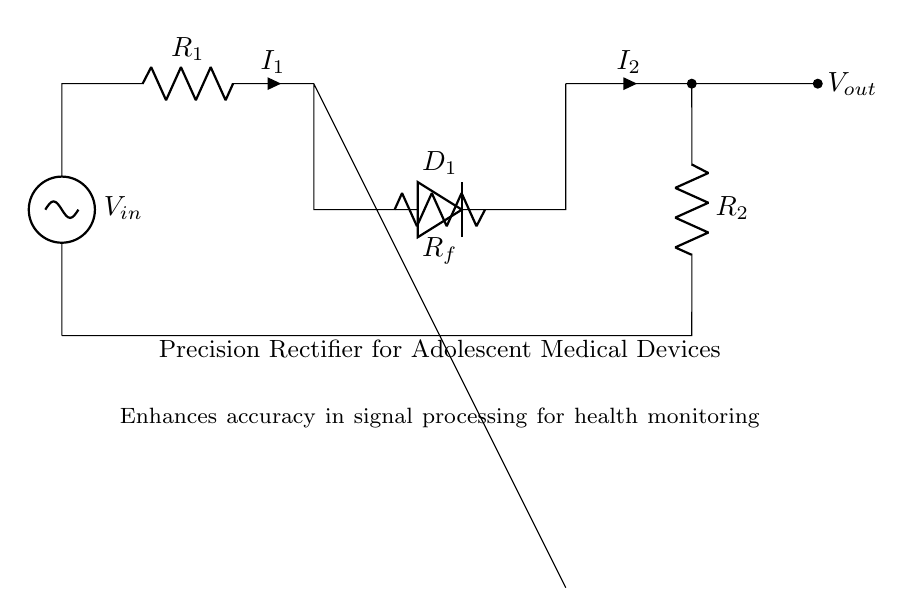What type of circuit is represented here? This circuit diagram represents a precision rectifier, which is designed to rectify small input signals accurately without the typical voltage drop found in standard diodes.
Answer: precision rectifier What are the main components in this circuit? The main components include two resistors (R1 and R2), one op-amp, and one diode (D1). These are essential for the functioning of the precision rectifier.
Answer: resistors, op-amp, diode What is the role of the op-amp in this circuit? The op-amp amplifies the input signal and helps in achieving precision rectification by controlling the behavior of the diode during the rectification process.
Answer: amplification What does the output voltage indicate? The output voltage (Vout) indicates the rectified version of the input voltage (Vin), processed by the precision rectifier to improve accuracy in low-level signals.
Answer: rectified voltage How many resistors are used in this circuit? There are two resistors in this circuit, labeled R1 and R2, which are crucial for determining the gain and feedback in the rectifier operation.
Answer: two What happens to the input signal if it is negative? If the input signal is negative, the diode will become reverse biased and effectively block the current, preventing a negative voltage at the output.
Answer: blocked signal What is the purpose of the diode D1 in this configuration? The diode D1 allows current to flow in one direction, thereby ensuring that only the positive part of the input signal is rectified, maintaining signal integrity.
Answer: rectification 